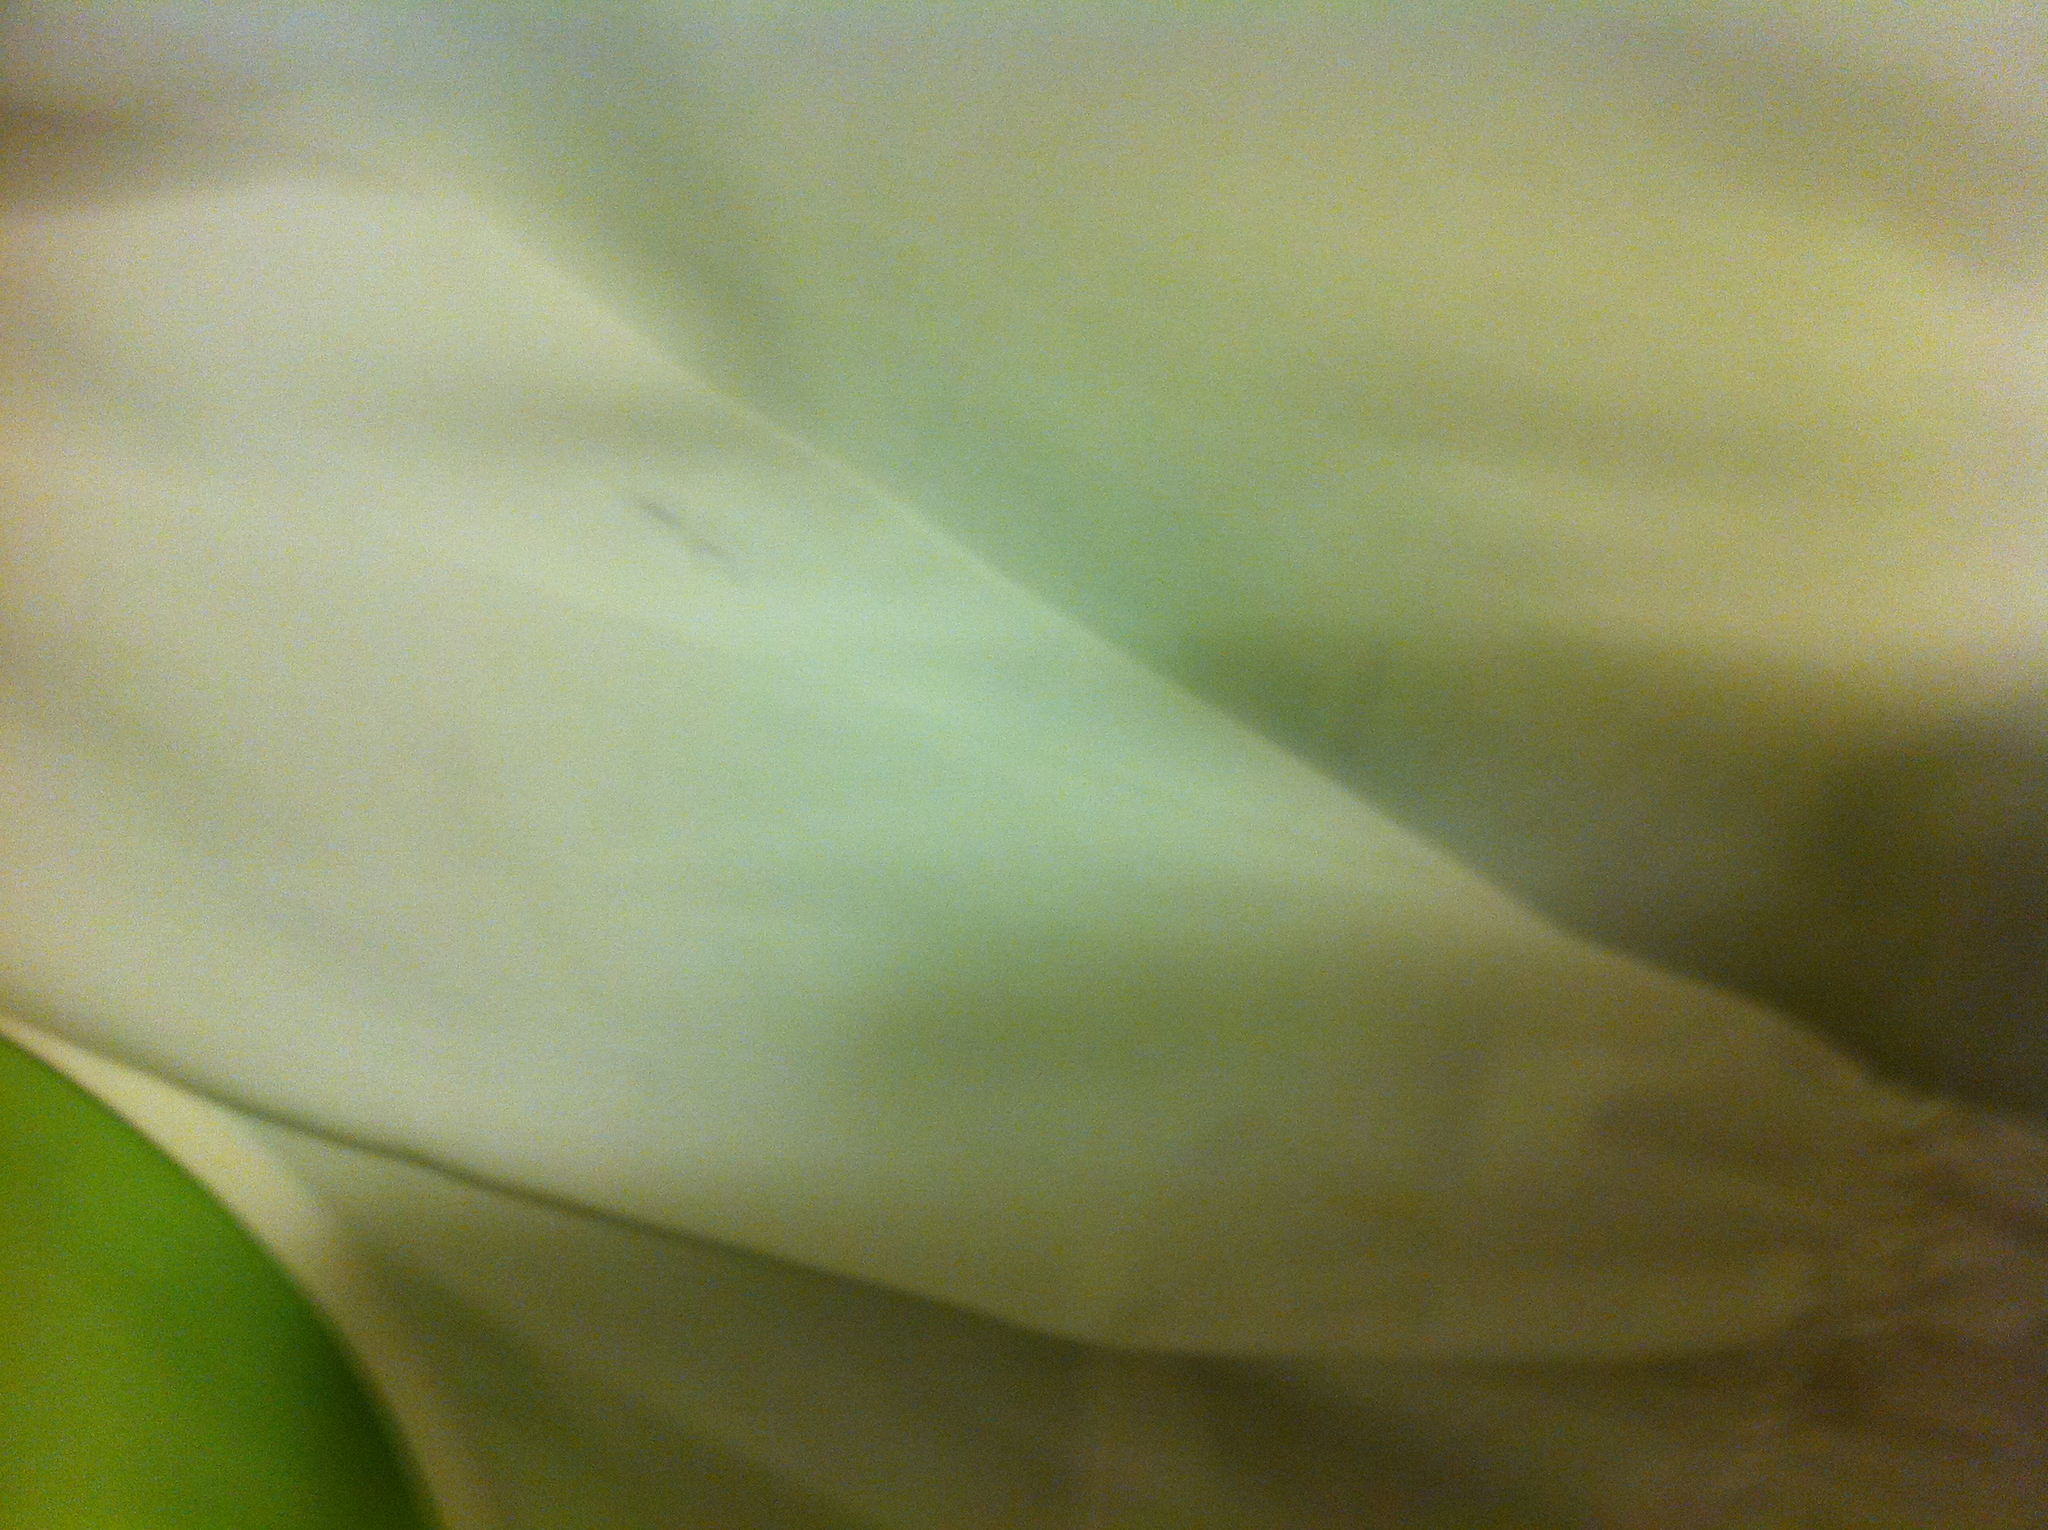How should I care for a shirt like this to maintain its color? To maintain the shirt's pristine white color, it should be washed with like colors, preferably with a detergent designed for whites. Avoiding bleach can prevent the fabric from yellowing, and hanging it to dry out of direct sunlight can also help preserve its brightness. 